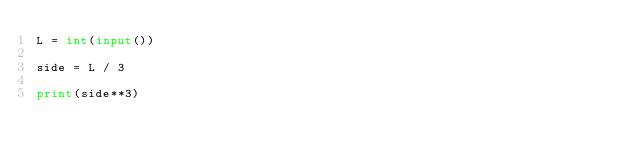Convert code to text. <code><loc_0><loc_0><loc_500><loc_500><_Python_>L = int(input())

side = L / 3

print(side**3)
</code> 